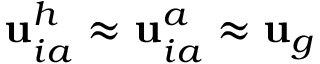<formula> <loc_0><loc_0><loc_500><loc_500>{ u } _ { i a } ^ { h } \approx { u } _ { i a } ^ { a } \approx { u } _ { g }</formula> 